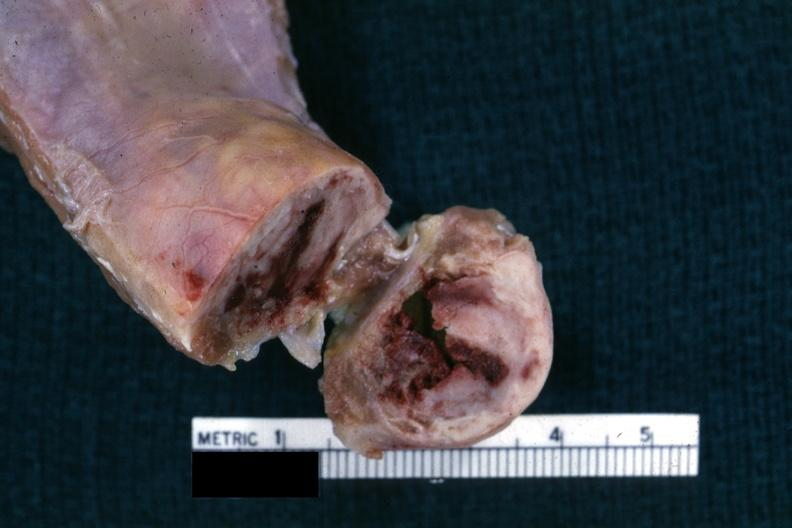does calculi show close-up view of cross sectioned rib lesion showing white neoplastic lesion with hemorrhagic center?
Answer the question using a single word or phrase. No 